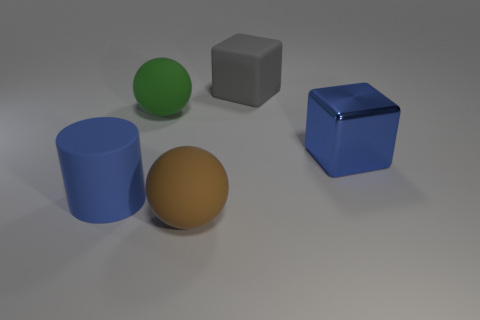Do the cube that is in front of the big gray object and the matte cylinder that is left of the blue shiny block have the same color?
Provide a succinct answer. Yes. What is the size of the blue object left of the big rubber ball to the left of the large brown rubber sphere that is in front of the large blue metal object?
Offer a very short reply. Large. What is the large gray cube made of?
Ensure brevity in your answer.  Rubber. There is a big blue thing that is left of the cube that is behind the large blue cube; what is its shape?
Your answer should be compact. Cylinder. What is the shape of the big rubber object that is behind the green sphere?
Make the answer very short. Cube. What number of big cylinders have the same color as the big metallic block?
Your answer should be very brief. 1. What is the color of the metal block?
Make the answer very short. Blue. What number of big spheres are on the right side of the matte sphere behind the blue cube?
Offer a very short reply. 1. Does the metal block have the same size as the cylinder?
Provide a short and direct response. Yes. Is there a red object of the same size as the blue metal thing?
Offer a terse response. No. 